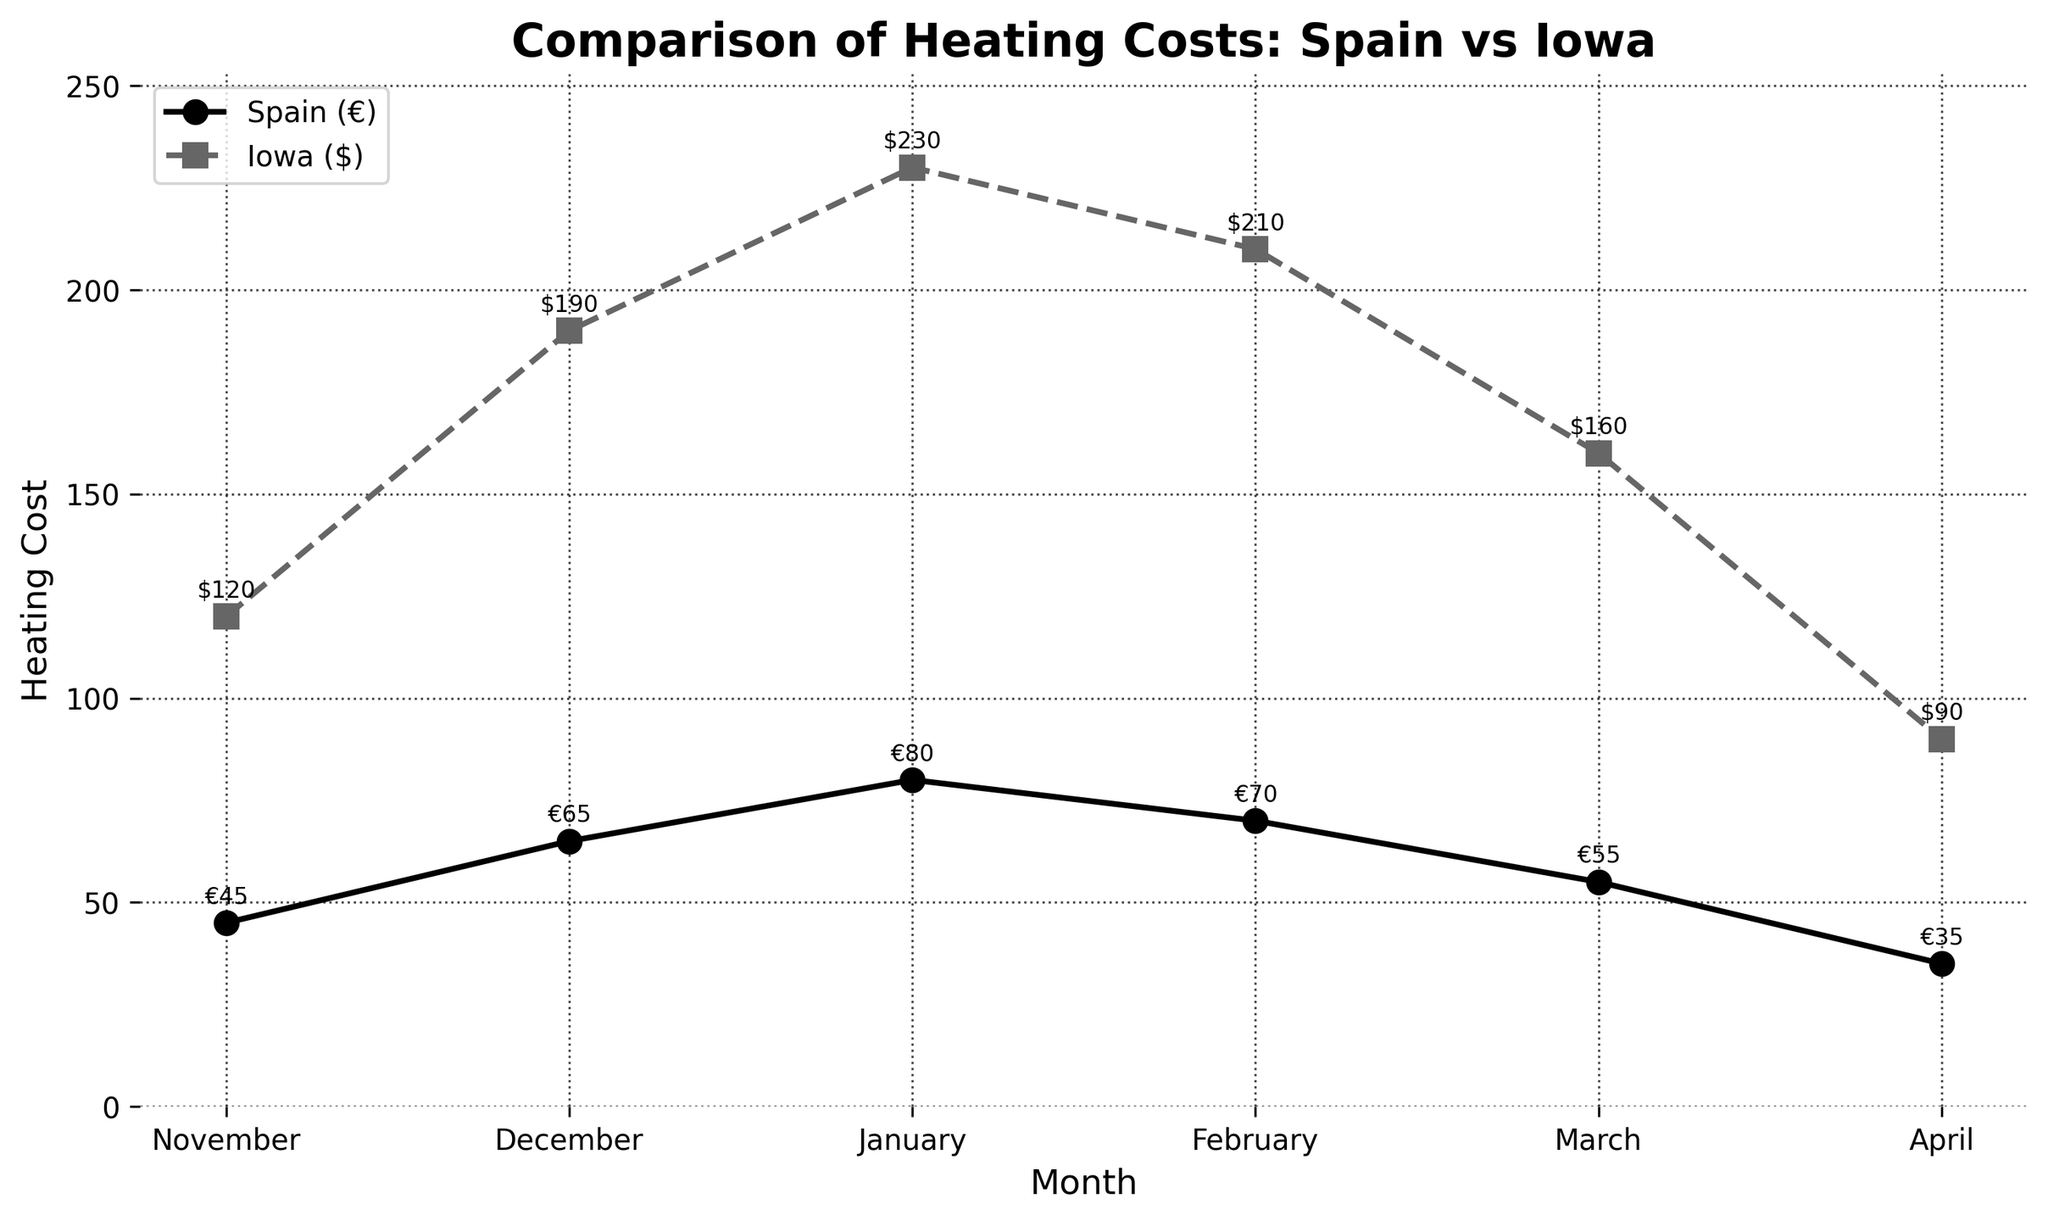Which month has the highest heating cost in Iowa? From the line chart, locate the month with the peak value on the Iowa Heating Cost ($) line, which is marked with a square marker. January shows the highest point.
Answer: January Compare the heating costs in Spain and Iowa for December. Which one is higher and by how much? Identify the values for Spain (65€) and Iowa ($190) in December. Convert Spain's cost to dollars (given the conversion rate is not known, the comparison is made directly). Calculate the difference, which is $190 - €65.
Answer: Iowa is higher by $125 What is the average heating cost in Spain from November to April? Add the heating costs for each month in Spain (45 + 65 + 80 + 70 + 55 + 35) and then divide by the number of months (6). The sum is 350, so the average is 350/6.
Answer: 58.33€ How does the heating cost in Iowa change from December to January? Identify the costs for December ($190) and January ($230). Subtract December's cost from January's cost to find the increase ($230 - $190). The increase is $40.
Answer: Increased by $40 Which month shows the least discrepancy between heating costs in Spain and Iowa? For each month, compute the absolute difference between Spain and Iowa's costs: November (75), December (125), January (150), February (140), March (105), and April (55). The smallest difference is in April.
Answer: April Is there any month where Spain's heating cost is higher than Iowa's? Compare the values for each month from both Spain and Iowa. In every month, Iowa's heating cost is higher than Spain's.
Answer: No By how much does Iowa's heating cost decrease from January to February? Identify the costs for January ($230) and February ($210). Subtract February's cost from January's cost to find the decrease ($230 - $210). The decrease is $20.
Answer: Decreased by $20 What is the total heating cost in Iowa for the entire period from November to April? Add the heating costs for each month in Iowa (120 + 190 + 230 + 210 + 160 + 90). The sum is 1000.
Answer: $1000 